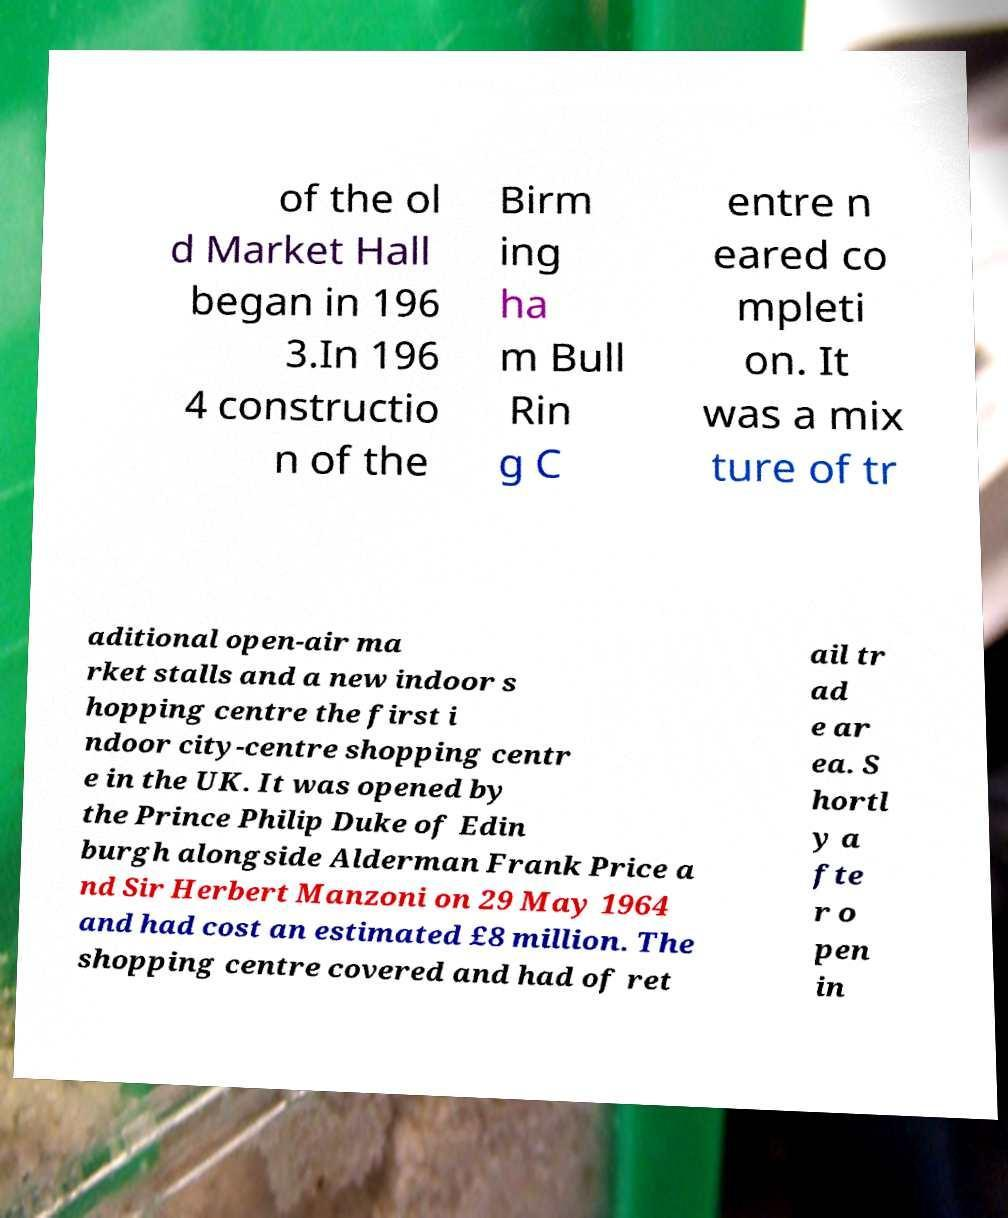Could you extract and type out the text from this image? of the ol d Market Hall began in 196 3.In 196 4 constructio n of the Birm ing ha m Bull Rin g C entre n eared co mpleti on. It was a mix ture of tr aditional open-air ma rket stalls and a new indoor s hopping centre the first i ndoor city-centre shopping centr e in the UK. It was opened by the Prince Philip Duke of Edin burgh alongside Alderman Frank Price a nd Sir Herbert Manzoni on 29 May 1964 and had cost an estimated £8 million. The shopping centre covered and had of ret ail tr ad e ar ea. S hortl y a fte r o pen in 